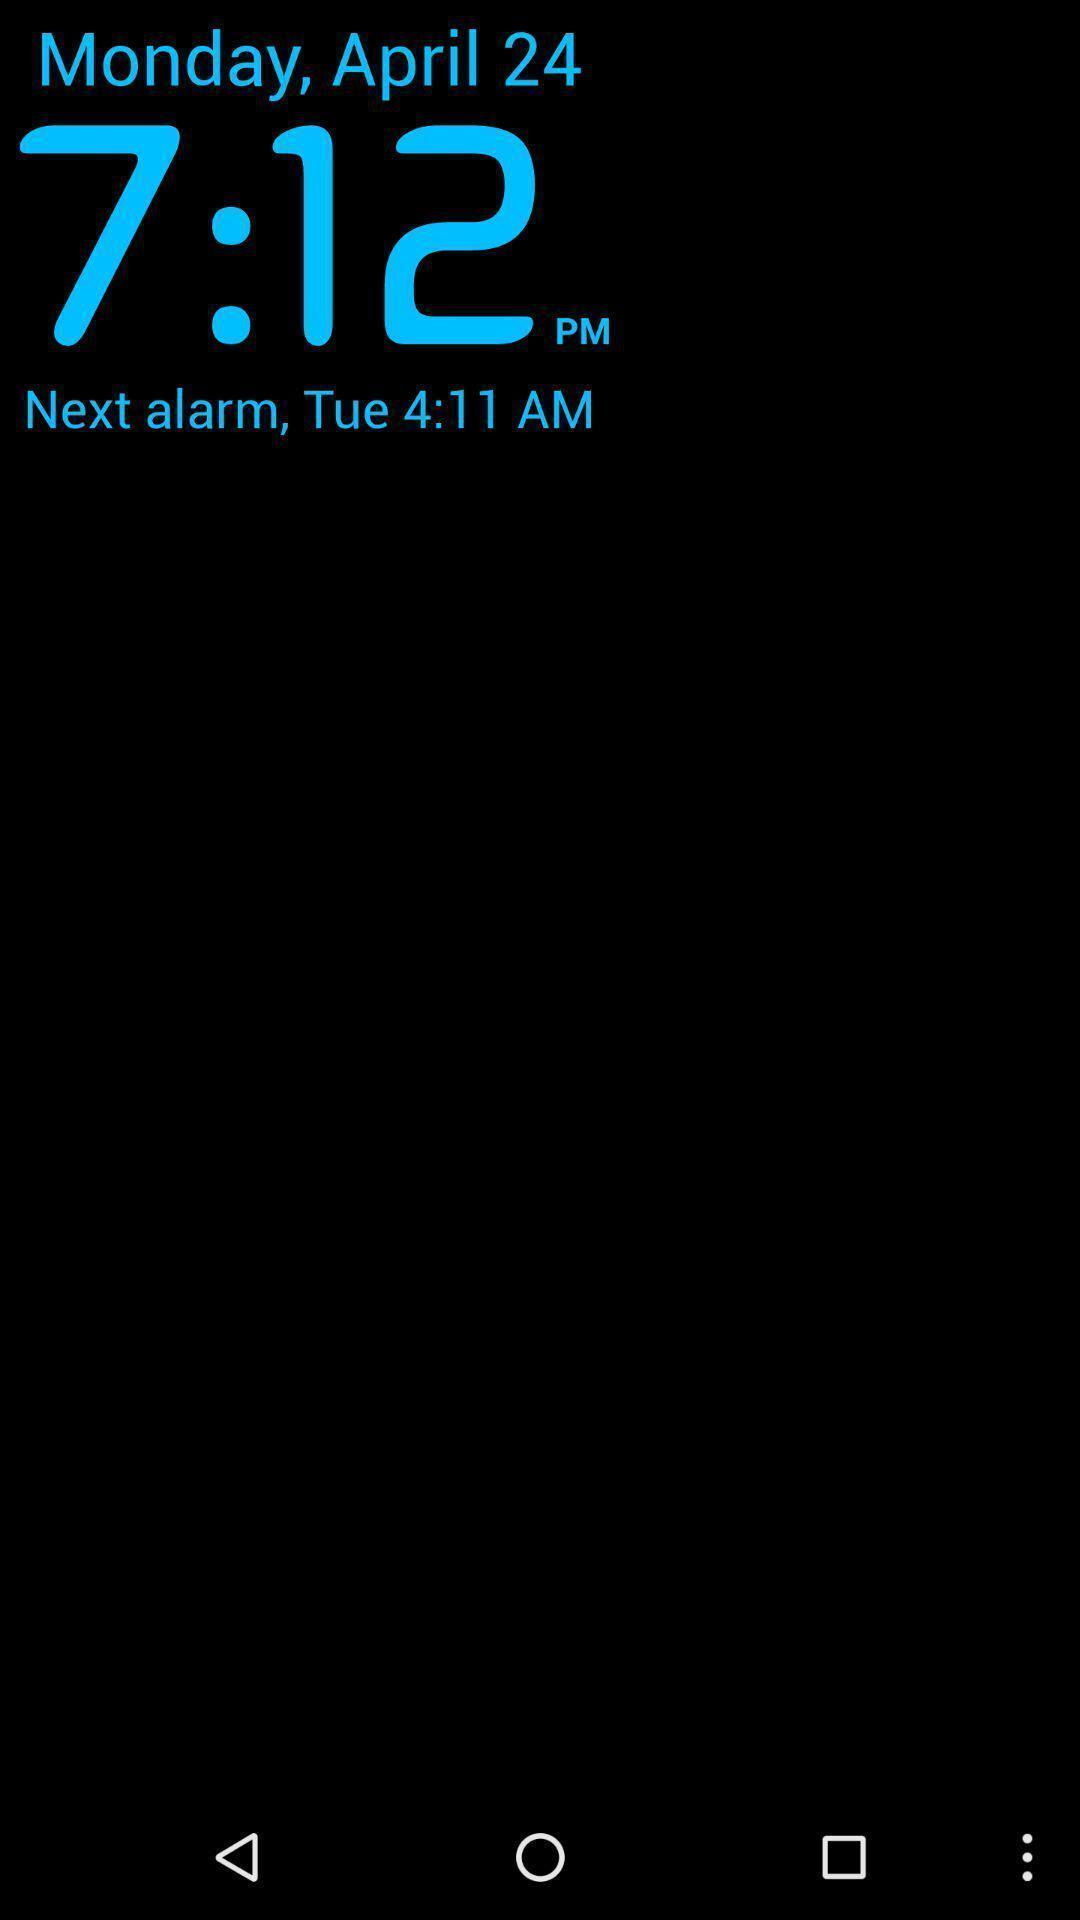Provide a textual representation of this image. Screen showing date and time with next alarm. 